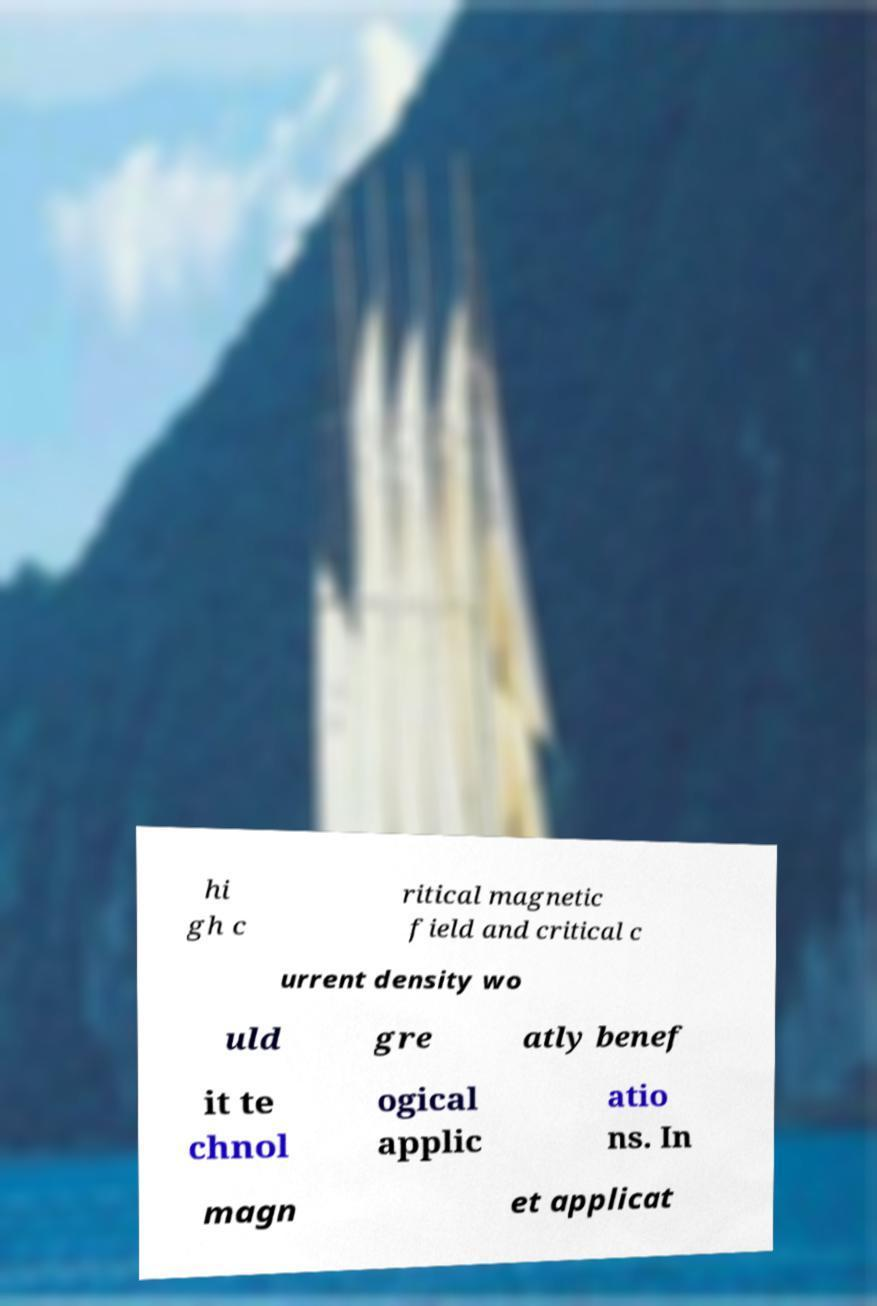Can you accurately transcribe the text from the provided image for me? hi gh c ritical magnetic field and critical c urrent density wo uld gre atly benef it te chnol ogical applic atio ns. In magn et applicat 